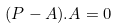<formula> <loc_0><loc_0><loc_500><loc_500>( P - A ) . A = 0</formula> 